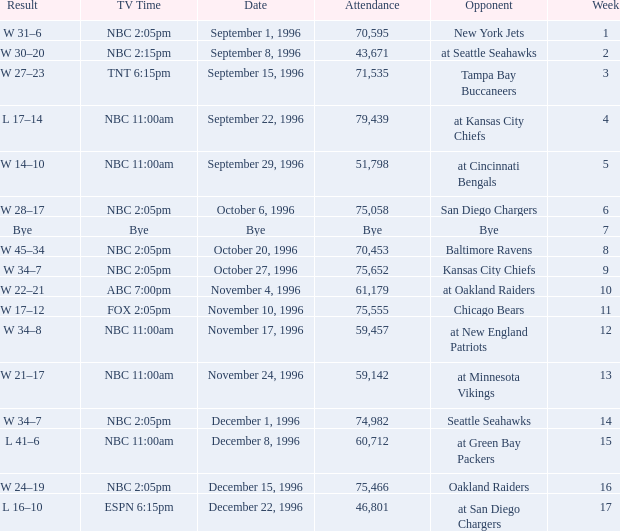WHAT IS THE WEEK WITH AN ATTENDANCE OF 75,555? 11.0. 